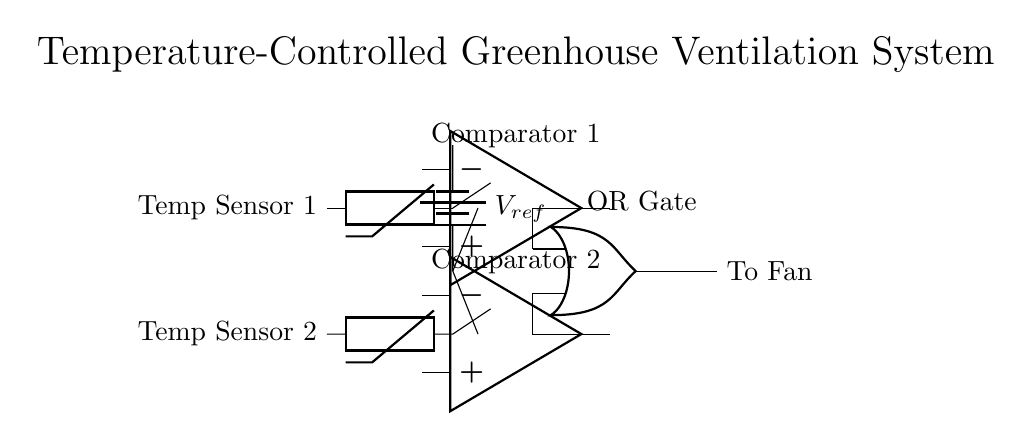What components are used in this circuit diagram? The components include two temperature sensors, two comparators, a reference voltage source, and an OR gate. These components work together in the temperature-controlled greenhouse ventilation system.
Answer: Temperature sensors, comparators, reference voltage source, OR gate What is the function of the OR gate in this circuit? The OR gate combines the outputs from the two comparators. If either comparator indicates that the temperature exceeds the reference level, the OR gate sends a signal to activate the fan for ventilation.
Answer: Combine outputs from comparators How many temperature sensors are present in the circuit? The circuit contains two temperature sensors connected to separate comparators. Each sensor measures temperature independently.
Answer: Two What do the comparators compare in this circuit? The comparators compare the voltage levels from the temperature sensors against the reference voltage source to determine if the environmental conditions require ventilation.
Answer: Sensor voltage and reference voltage If both comparators detect a high temperature, what will be the output of the OR gate? If both comparators indicate high temperatures, the output of the OR gate will be high, signifying activation of the fan. This ensures sufficient ventilation if either sensor triggers the condition.
Answer: High What role does the reference voltage play in this circuit? The reference voltage serves as a threshold level for the comparators, dictating when the circuit should trigger ventilation based on the temperatures detected by the sensors.
Answer: Threshold for comparators 